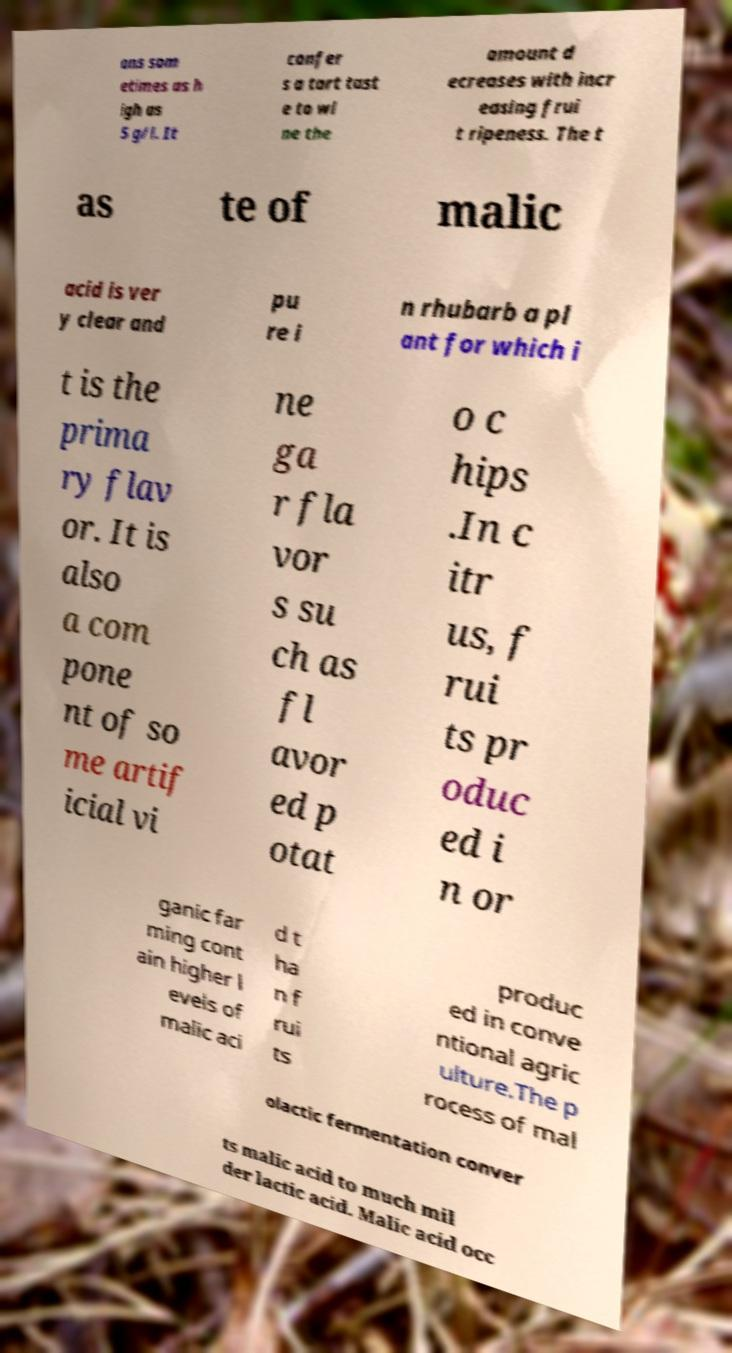Could you assist in decoding the text presented in this image and type it out clearly? ons som etimes as h igh as 5 g/l. It confer s a tart tast e to wi ne the amount d ecreases with incr easing frui t ripeness. The t as te of malic acid is ver y clear and pu re i n rhubarb a pl ant for which i t is the prima ry flav or. It is also a com pone nt of so me artif icial vi ne ga r fla vor s su ch as fl avor ed p otat o c hips .In c itr us, f rui ts pr oduc ed i n or ganic far ming cont ain higher l evels of malic aci d t ha n f rui ts produc ed in conve ntional agric ulture.The p rocess of mal olactic fermentation conver ts malic acid to much mil der lactic acid. Malic acid occ 